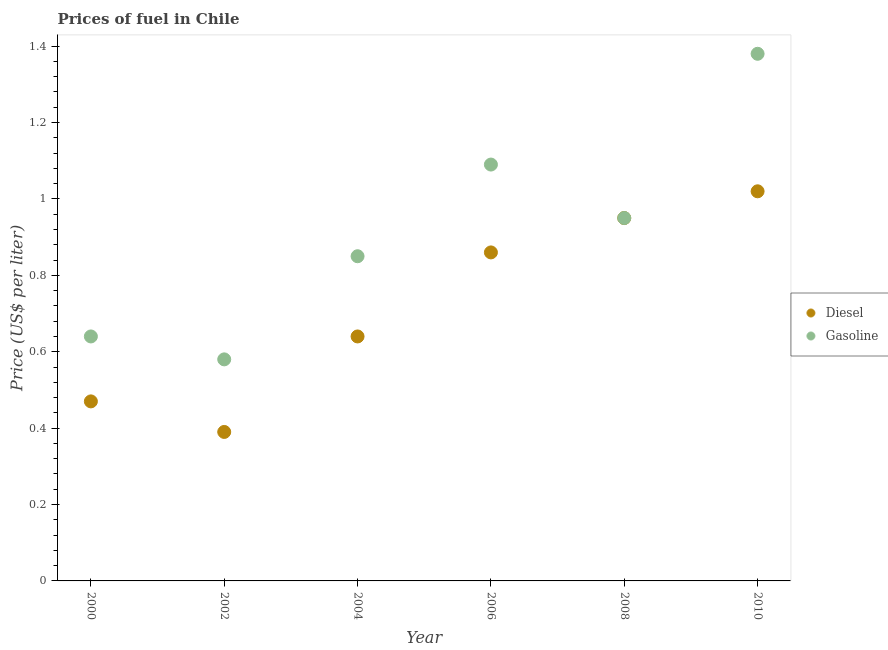Across all years, what is the maximum diesel price?
Provide a succinct answer. 1.02. Across all years, what is the minimum diesel price?
Your answer should be very brief. 0.39. In which year was the gasoline price maximum?
Provide a succinct answer. 2010. What is the total gasoline price in the graph?
Your answer should be compact. 5.49. What is the difference between the gasoline price in 2006 and that in 2008?
Give a very brief answer. 0.14. What is the difference between the gasoline price in 2002 and the diesel price in 2000?
Ensure brevity in your answer.  0.11. What is the average diesel price per year?
Your answer should be very brief. 0.72. In the year 2004, what is the difference between the gasoline price and diesel price?
Your answer should be very brief. 0.21. What is the ratio of the diesel price in 2002 to that in 2004?
Make the answer very short. 0.61. Is the diesel price in 2002 less than that in 2008?
Offer a very short reply. Yes. What is the difference between the highest and the second highest diesel price?
Ensure brevity in your answer.  0.07. What is the difference between the highest and the lowest gasoline price?
Offer a terse response. 0.8. Is the sum of the gasoline price in 2000 and 2002 greater than the maximum diesel price across all years?
Your answer should be compact. Yes. Is the gasoline price strictly greater than the diesel price over the years?
Your response must be concise. No. How many years are there in the graph?
Offer a very short reply. 6. Does the graph contain any zero values?
Provide a succinct answer. No. What is the title of the graph?
Make the answer very short. Prices of fuel in Chile. What is the label or title of the Y-axis?
Offer a very short reply. Price (US$ per liter). What is the Price (US$ per liter) in Diesel in 2000?
Give a very brief answer. 0.47. What is the Price (US$ per liter) in Gasoline in 2000?
Give a very brief answer. 0.64. What is the Price (US$ per liter) in Diesel in 2002?
Your answer should be very brief. 0.39. What is the Price (US$ per liter) of Gasoline in 2002?
Offer a very short reply. 0.58. What is the Price (US$ per liter) of Diesel in 2004?
Provide a succinct answer. 0.64. What is the Price (US$ per liter) in Gasoline in 2004?
Your answer should be very brief. 0.85. What is the Price (US$ per liter) of Diesel in 2006?
Your answer should be compact. 0.86. What is the Price (US$ per liter) in Gasoline in 2006?
Make the answer very short. 1.09. What is the Price (US$ per liter) in Diesel in 2008?
Provide a short and direct response. 0.95. What is the Price (US$ per liter) of Gasoline in 2008?
Keep it short and to the point. 0.95. What is the Price (US$ per liter) in Diesel in 2010?
Offer a terse response. 1.02. What is the Price (US$ per liter) of Gasoline in 2010?
Your answer should be compact. 1.38. Across all years, what is the maximum Price (US$ per liter) in Gasoline?
Your answer should be very brief. 1.38. Across all years, what is the minimum Price (US$ per liter) in Diesel?
Provide a short and direct response. 0.39. Across all years, what is the minimum Price (US$ per liter) of Gasoline?
Offer a terse response. 0.58. What is the total Price (US$ per liter) of Diesel in the graph?
Your answer should be compact. 4.33. What is the total Price (US$ per liter) of Gasoline in the graph?
Ensure brevity in your answer.  5.49. What is the difference between the Price (US$ per liter) of Diesel in 2000 and that in 2002?
Make the answer very short. 0.08. What is the difference between the Price (US$ per liter) of Diesel in 2000 and that in 2004?
Offer a very short reply. -0.17. What is the difference between the Price (US$ per liter) of Gasoline in 2000 and that in 2004?
Provide a succinct answer. -0.21. What is the difference between the Price (US$ per liter) in Diesel in 2000 and that in 2006?
Give a very brief answer. -0.39. What is the difference between the Price (US$ per liter) in Gasoline in 2000 and that in 2006?
Your answer should be compact. -0.45. What is the difference between the Price (US$ per liter) in Diesel in 2000 and that in 2008?
Your answer should be very brief. -0.48. What is the difference between the Price (US$ per liter) of Gasoline in 2000 and that in 2008?
Keep it short and to the point. -0.31. What is the difference between the Price (US$ per liter) in Diesel in 2000 and that in 2010?
Your answer should be very brief. -0.55. What is the difference between the Price (US$ per liter) in Gasoline in 2000 and that in 2010?
Provide a short and direct response. -0.74. What is the difference between the Price (US$ per liter) of Gasoline in 2002 and that in 2004?
Provide a succinct answer. -0.27. What is the difference between the Price (US$ per liter) in Diesel in 2002 and that in 2006?
Give a very brief answer. -0.47. What is the difference between the Price (US$ per liter) in Gasoline in 2002 and that in 2006?
Make the answer very short. -0.51. What is the difference between the Price (US$ per liter) of Diesel in 2002 and that in 2008?
Give a very brief answer. -0.56. What is the difference between the Price (US$ per liter) in Gasoline in 2002 and that in 2008?
Offer a very short reply. -0.37. What is the difference between the Price (US$ per liter) of Diesel in 2002 and that in 2010?
Make the answer very short. -0.63. What is the difference between the Price (US$ per liter) in Diesel in 2004 and that in 2006?
Offer a terse response. -0.22. What is the difference between the Price (US$ per liter) of Gasoline in 2004 and that in 2006?
Offer a terse response. -0.24. What is the difference between the Price (US$ per liter) of Diesel in 2004 and that in 2008?
Offer a terse response. -0.31. What is the difference between the Price (US$ per liter) of Diesel in 2004 and that in 2010?
Offer a terse response. -0.38. What is the difference between the Price (US$ per liter) of Gasoline in 2004 and that in 2010?
Provide a succinct answer. -0.53. What is the difference between the Price (US$ per liter) in Diesel in 2006 and that in 2008?
Your answer should be compact. -0.09. What is the difference between the Price (US$ per liter) of Gasoline in 2006 and that in 2008?
Keep it short and to the point. 0.14. What is the difference between the Price (US$ per liter) of Diesel in 2006 and that in 2010?
Make the answer very short. -0.16. What is the difference between the Price (US$ per liter) in Gasoline in 2006 and that in 2010?
Your answer should be very brief. -0.29. What is the difference between the Price (US$ per liter) in Diesel in 2008 and that in 2010?
Your answer should be compact. -0.07. What is the difference between the Price (US$ per liter) in Gasoline in 2008 and that in 2010?
Keep it short and to the point. -0.43. What is the difference between the Price (US$ per liter) in Diesel in 2000 and the Price (US$ per liter) in Gasoline in 2002?
Your response must be concise. -0.11. What is the difference between the Price (US$ per liter) of Diesel in 2000 and the Price (US$ per liter) of Gasoline in 2004?
Make the answer very short. -0.38. What is the difference between the Price (US$ per liter) of Diesel in 2000 and the Price (US$ per liter) of Gasoline in 2006?
Provide a succinct answer. -0.62. What is the difference between the Price (US$ per liter) of Diesel in 2000 and the Price (US$ per liter) of Gasoline in 2008?
Give a very brief answer. -0.48. What is the difference between the Price (US$ per liter) in Diesel in 2000 and the Price (US$ per liter) in Gasoline in 2010?
Your answer should be compact. -0.91. What is the difference between the Price (US$ per liter) of Diesel in 2002 and the Price (US$ per liter) of Gasoline in 2004?
Provide a succinct answer. -0.46. What is the difference between the Price (US$ per liter) of Diesel in 2002 and the Price (US$ per liter) of Gasoline in 2008?
Provide a short and direct response. -0.56. What is the difference between the Price (US$ per liter) of Diesel in 2002 and the Price (US$ per liter) of Gasoline in 2010?
Offer a very short reply. -0.99. What is the difference between the Price (US$ per liter) of Diesel in 2004 and the Price (US$ per liter) of Gasoline in 2006?
Your answer should be compact. -0.45. What is the difference between the Price (US$ per liter) in Diesel in 2004 and the Price (US$ per liter) in Gasoline in 2008?
Provide a succinct answer. -0.31. What is the difference between the Price (US$ per liter) in Diesel in 2004 and the Price (US$ per liter) in Gasoline in 2010?
Provide a succinct answer. -0.74. What is the difference between the Price (US$ per liter) of Diesel in 2006 and the Price (US$ per liter) of Gasoline in 2008?
Make the answer very short. -0.09. What is the difference between the Price (US$ per liter) in Diesel in 2006 and the Price (US$ per liter) in Gasoline in 2010?
Keep it short and to the point. -0.52. What is the difference between the Price (US$ per liter) in Diesel in 2008 and the Price (US$ per liter) in Gasoline in 2010?
Offer a terse response. -0.43. What is the average Price (US$ per liter) of Diesel per year?
Offer a terse response. 0.72. What is the average Price (US$ per liter) of Gasoline per year?
Provide a succinct answer. 0.92. In the year 2000, what is the difference between the Price (US$ per liter) in Diesel and Price (US$ per liter) in Gasoline?
Provide a short and direct response. -0.17. In the year 2002, what is the difference between the Price (US$ per liter) in Diesel and Price (US$ per liter) in Gasoline?
Give a very brief answer. -0.19. In the year 2004, what is the difference between the Price (US$ per liter) in Diesel and Price (US$ per liter) in Gasoline?
Make the answer very short. -0.21. In the year 2006, what is the difference between the Price (US$ per liter) of Diesel and Price (US$ per liter) of Gasoline?
Make the answer very short. -0.23. In the year 2010, what is the difference between the Price (US$ per liter) of Diesel and Price (US$ per liter) of Gasoline?
Give a very brief answer. -0.36. What is the ratio of the Price (US$ per liter) of Diesel in 2000 to that in 2002?
Provide a short and direct response. 1.21. What is the ratio of the Price (US$ per liter) of Gasoline in 2000 to that in 2002?
Offer a very short reply. 1.1. What is the ratio of the Price (US$ per liter) of Diesel in 2000 to that in 2004?
Offer a terse response. 0.73. What is the ratio of the Price (US$ per liter) in Gasoline in 2000 to that in 2004?
Keep it short and to the point. 0.75. What is the ratio of the Price (US$ per liter) of Diesel in 2000 to that in 2006?
Give a very brief answer. 0.55. What is the ratio of the Price (US$ per liter) of Gasoline in 2000 to that in 2006?
Make the answer very short. 0.59. What is the ratio of the Price (US$ per liter) in Diesel in 2000 to that in 2008?
Give a very brief answer. 0.49. What is the ratio of the Price (US$ per liter) in Gasoline in 2000 to that in 2008?
Your response must be concise. 0.67. What is the ratio of the Price (US$ per liter) in Diesel in 2000 to that in 2010?
Give a very brief answer. 0.46. What is the ratio of the Price (US$ per liter) in Gasoline in 2000 to that in 2010?
Provide a succinct answer. 0.46. What is the ratio of the Price (US$ per liter) in Diesel in 2002 to that in 2004?
Your answer should be compact. 0.61. What is the ratio of the Price (US$ per liter) of Gasoline in 2002 to that in 2004?
Your answer should be compact. 0.68. What is the ratio of the Price (US$ per liter) in Diesel in 2002 to that in 2006?
Give a very brief answer. 0.45. What is the ratio of the Price (US$ per liter) of Gasoline in 2002 to that in 2006?
Provide a succinct answer. 0.53. What is the ratio of the Price (US$ per liter) of Diesel in 2002 to that in 2008?
Provide a succinct answer. 0.41. What is the ratio of the Price (US$ per liter) of Gasoline in 2002 to that in 2008?
Make the answer very short. 0.61. What is the ratio of the Price (US$ per liter) in Diesel in 2002 to that in 2010?
Make the answer very short. 0.38. What is the ratio of the Price (US$ per liter) in Gasoline in 2002 to that in 2010?
Offer a terse response. 0.42. What is the ratio of the Price (US$ per liter) in Diesel in 2004 to that in 2006?
Offer a very short reply. 0.74. What is the ratio of the Price (US$ per liter) in Gasoline in 2004 to that in 2006?
Keep it short and to the point. 0.78. What is the ratio of the Price (US$ per liter) in Diesel in 2004 to that in 2008?
Offer a very short reply. 0.67. What is the ratio of the Price (US$ per liter) in Gasoline in 2004 to that in 2008?
Your answer should be compact. 0.89. What is the ratio of the Price (US$ per liter) of Diesel in 2004 to that in 2010?
Provide a short and direct response. 0.63. What is the ratio of the Price (US$ per liter) of Gasoline in 2004 to that in 2010?
Give a very brief answer. 0.62. What is the ratio of the Price (US$ per liter) of Diesel in 2006 to that in 2008?
Offer a terse response. 0.91. What is the ratio of the Price (US$ per liter) in Gasoline in 2006 to that in 2008?
Ensure brevity in your answer.  1.15. What is the ratio of the Price (US$ per liter) of Diesel in 2006 to that in 2010?
Provide a succinct answer. 0.84. What is the ratio of the Price (US$ per liter) of Gasoline in 2006 to that in 2010?
Provide a short and direct response. 0.79. What is the ratio of the Price (US$ per liter) in Diesel in 2008 to that in 2010?
Your answer should be compact. 0.93. What is the ratio of the Price (US$ per liter) of Gasoline in 2008 to that in 2010?
Ensure brevity in your answer.  0.69. What is the difference between the highest and the second highest Price (US$ per liter) of Diesel?
Keep it short and to the point. 0.07. What is the difference between the highest and the second highest Price (US$ per liter) of Gasoline?
Ensure brevity in your answer.  0.29. What is the difference between the highest and the lowest Price (US$ per liter) in Diesel?
Keep it short and to the point. 0.63. 